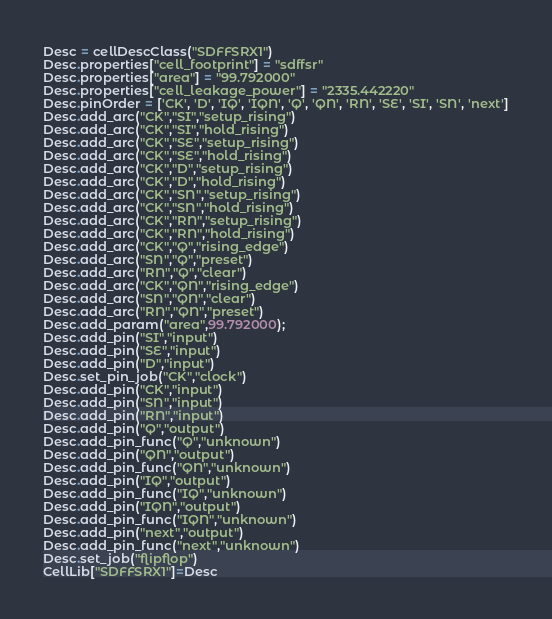<code> <loc_0><loc_0><loc_500><loc_500><_Python_>Desc = cellDescClass("SDFFSRX1")
Desc.properties["cell_footprint"] = "sdffsr"
Desc.properties["area"] = "99.792000"
Desc.properties["cell_leakage_power"] = "2335.442220"
Desc.pinOrder = ['CK', 'D', 'IQ', 'IQN', 'Q', 'QN', 'RN', 'SE', 'SI', 'SN', 'next']
Desc.add_arc("CK","SI","setup_rising")
Desc.add_arc("CK","SI","hold_rising")
Desc.add_arc("CK","SE","setup_rising")
Desc.add_arc("CK","SE","hold_rising")
Desc.add_arc("CK","D","setup_rising")
Desc.add_arc("CK","D","hold_rising")
Desc.add_arc("CK","SN","setup_rising")
Desc.add_arc("CK","SN","hold_rising")
Desc.add_arc("CK","RN","setup_rising")
Desc.add_arc("CK","RN","hold_rising")
Desc.add_arc("CK","Q","rising_edge")
Desc.add_arc("SN","Q","preset")
Desc.add_arc("RN","Q","clear")
Desc.add_arc("CK","QN","rising_edge")
Desc.add_arc("SN","QN","clear")
Desc.add_arc("RN","QN","preset")
Desc.add_param("area",99.792000);
Desc.add_pin("SI","input")
Desc.add_pin("SE","input")
Desc.add_pin("D","input")
Desc.set_pin_job("CK","clock")
Desc.add_pin("CK","input")
Desc.add_pin("SN","input")
Desc.add_pin("RN","input")
Desc.add_pin("Q","output")
Desc.add_pin_func("Q","unknown")
Desc.add_pin("QN","output")
Desc.add_pin_func("QN","unknown")
Desc.add_pin("IQ","output")
Desc.add_pin_func("IQ","unknown")
Desc.add_pin("IQN","output")
Desc.add_pin_func("IQN","unknown")
Desc.add_pin("next","output")
Desc.add_pin_func("next","unknown")
Desc.set_job("flipflop")
CellLib["SDFFSRX1"]=Desc
</code> 